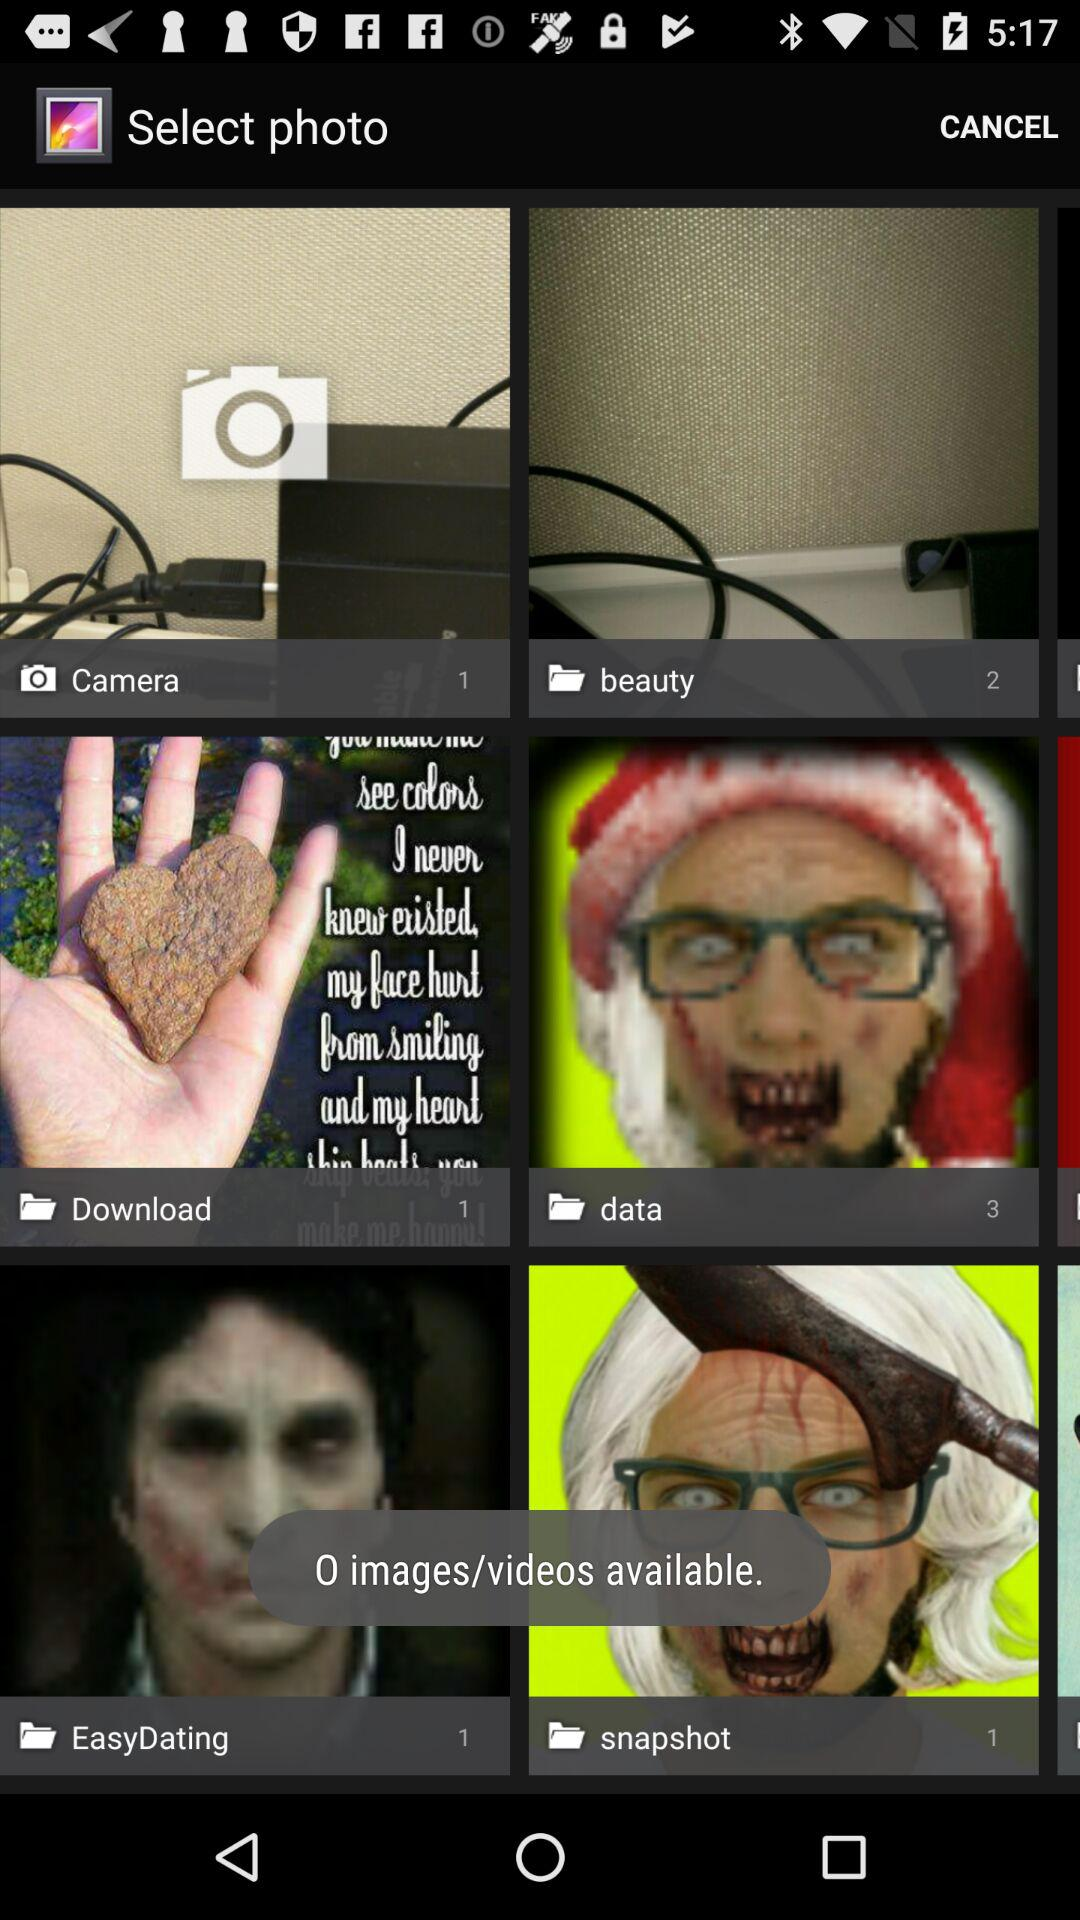How many photos are there in the "Download" folder? The number of photos in the "Download" folder is 1. 